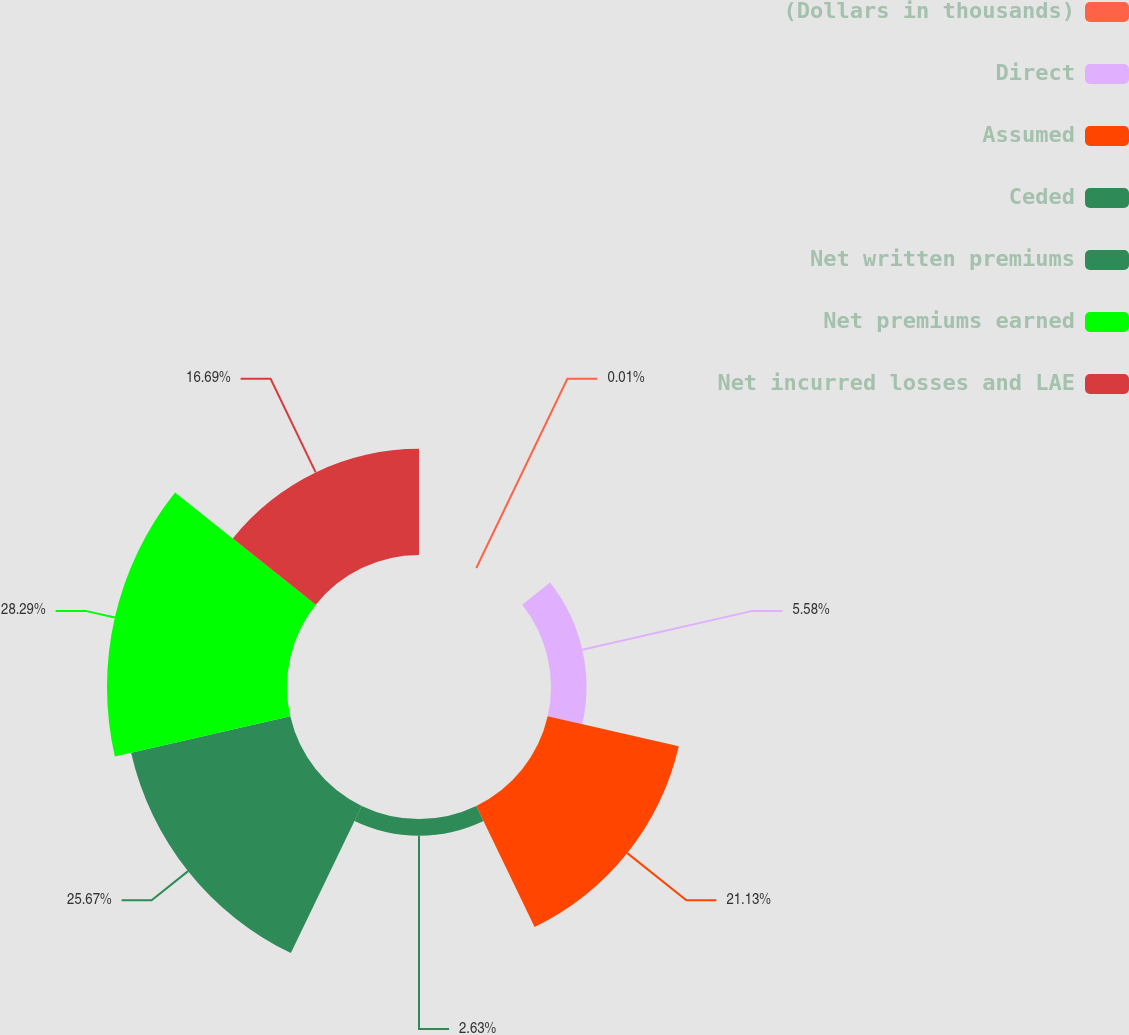<chart> <loc_0><loc_0><loc_500><loc_500><pie_chart><fcel>(Dollars in thousands)<fcel>Direct<fcel>Assumed<fcel>Ceded<fcel>Net written premiums<fcel>Net premiums earned<fcel>Net incurred losses and LAE<nl><fcel>0.01%<fcel>5.58%<fcel>21.13%<fcel>2.63%<fcel>25.67%<fcel>28.29%<fcel>16.69%<nl></chart> 